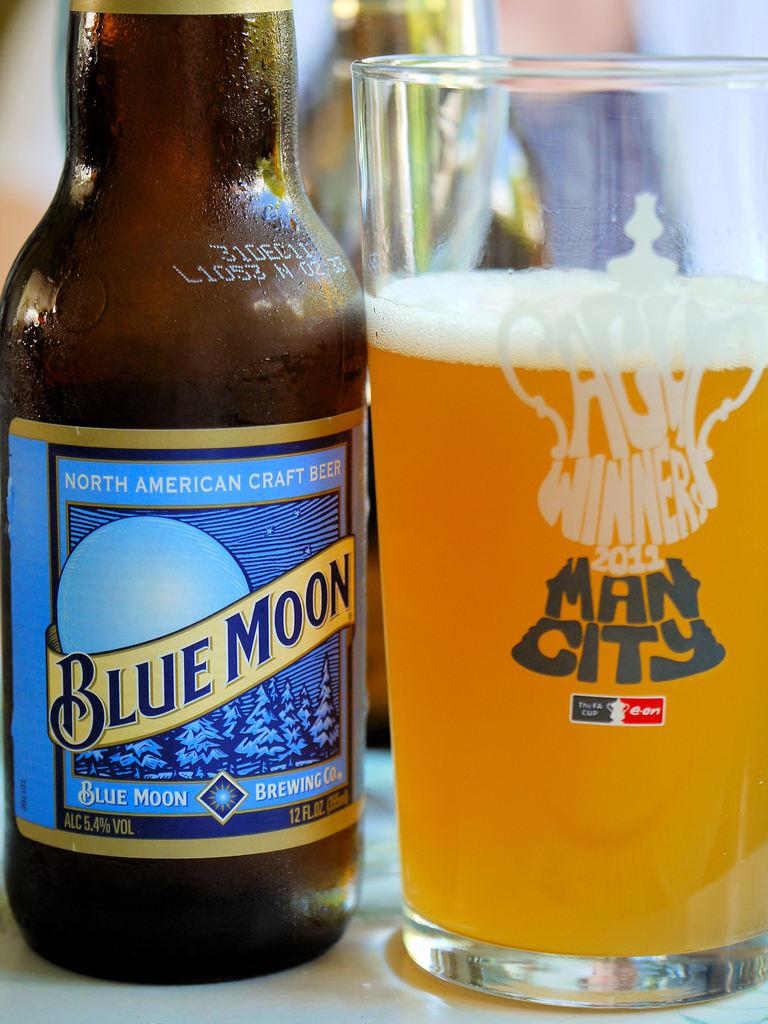What is on the table in the image? There is a beer bottle and a glass full of beer on the table in the image. What type of container is holding the beer? The beer is in a glass and a beer bottle. Can you describe the beer bottle in the image? The beer bottle has a label attached to it. What invention is being demonstrated by the ants in the image? There are no ants present in the image, so no invention can be demonstrated by them. 